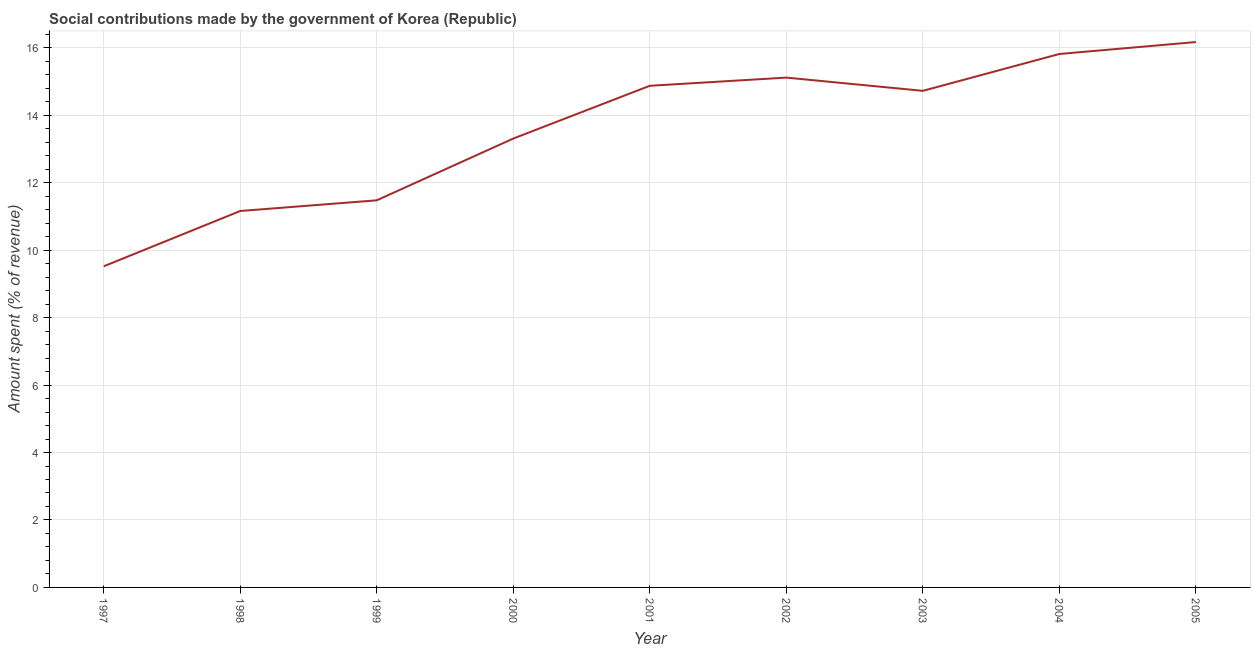What is the amount spent in making social contributions in 1997?
Offer a terse response. 9.52. Across all years, what is the maximum amount spent in making social contributions?
Give a very brief answer. 16.17. Across all years, what is the minimum amount spent in making social contributions?
Ensure brevity in your answer.  9.52. In which year was the amount spent in making social contributions maximum?
Give a very brief answer. 2005. What is the sum of the amount spent in making social contributions?
Offer a very short reply. 122.18. What is the difference between the amount spent in making social contributions in 1997 and 2002?
Offer a terse response. -5.6. What is the average amount spent in making social contributions per year?
Give a very brief answer. 13.58. What is the median amount spent in making social contributions?
Provide a short and direct response. 14.72. What is the ratio of the amount spent in making social contributions in 1999 to that in 2003?
Make the answer very short. 0.78. Is the difference between the amount spent in making social contributions in 1998 and 2003 greater than the difference between any two years?
Offer a very short reply. No. What is the difference between the highest and the second highest amount spent in making social contributions?
Keep it short and to the point. 0.35. Is the sum of the amount spent in making social contributions in 1998 and 2004 greater than the maximum amount spent in making social contributions across all years?
Provide a short and direct response. Yes. What is the difference between the highest and the lowest amount spent in making social contributions?
Your answer should be compact. 6.65. In how many years, is the amount spent in making social contributions greater than the average amount spent in making social contributions taken over all years?
Your answer should be compact. 5. Does the amount spent in making social contributions monotonically increase over the years?
Ensure brevity in your answer.  No. How many lines are there?
Keep it short and to the point. 1. What is the difference between two consecutive major ticks on the Y-axis?
Provide a short and direct response. 2. Are the values on the major ticks of Y-axis written in scientific E-notation?
Make the answer very short. No. Does the graph contain grids?
Provide a short and direct response. Yes. What is the title of the graph?
Ensure brevity in your answer.  Social contributions made by the government of Korea (Republic). What is the label or title of the X-axis?
Offer a terse response. Year. What is the label or title of the Y-axis?
Provide a short and direct response. Amount spent (% of revenue). What is the Amount spent (% of revenue) of 1997?
Your response must be concise. 9.52. What is the Amount spent (% of revenue) in 1998?
Provide a succinct answer. 11.16. What is the Amount spent (% of revenue) in 1999?
Make the answer very short. 11.48. What is the Amount spent (% of revenue) in 2000?
Provide a short and direct response. 13.31. What is the Amount spent (% of revenue) in 2001?
Make the answer very short. 14.87. What is the Amount spent (% of revenue) of 2002?
Offer a very short reply. 15.12. What is the Amount spent (% of revenue) in 2003?
Give a very brief answer. 14.72. What is the Amount spent (% of revenue) of 2004?
Keep it short and to the point. 15.82. What is the Amount spent (% of revenue) of 2005?
Make the answer very short. 16.17. What is the difference between the Amount spent (% of revenue) in 1997 and 1998?
Offer a terse response. -1.64. What is the difference between the Amount spent (% of revenue) in 1997 and 1999?
Provide a short and direct response. -1.96. What is the difference between the Amount spent (% of revenue) in 1997 and 2000?
Your answer should be compact. -3.79. What is the difference between the Amount spent (% of revenue) in 1997 and 2001?
Offer a terse response. -5.35. What is the difference between the Amount spent (% of revenue) in 1997 and 2002?
Make the answer very short. -5.6. What is the difference between the Amount spent (% of revenue) in 1997 and 2003?
Your answer should be compact. -5.2. What is the difference between the Amount spent (% of revenue) in 1997 and 2004?
Give a very brief answer. -6.3. What is the difference between the Amount spent (% of revenue) in 1997 and 2005?
Provide a succinct answer. -6.65. What is the difference between the Amount spent (% of revenue) in 1998 and 1999?
Keep it short and to the point. -0.32. What is the difference between the Amount spent (% of revenue) in 1998 and 2000?
Make the answer very short. -2.15. What is the difference between the Amount spent (% of revenue) in 1998 and 2001?
Keep it short and to the point. -3.71. What is the difference between the Amount spent (% of revenue) in 1998 and 2002?
Offer a very short reply. -3.96. What is the difference between the Amount spent (% of revenue) in 1998 and 2003?
Your answer should be compact. -3.56. What is the difference between the Amount spent (% of revenue) in 1998 and 2004?
Ensure brevity in your answer.  -4.66. What is the difference between the Amount spent (% of revenue) in 1998 and 2005?
Give a very brief answer. -5.01. What is the difference between the Amount spent (% of revenue) in 1999 and 2000?
Offer a very short reply. -1.83. What is the difference between the Amount spent (% of revenue) in 1999 and 2001?
Your response must be concise. -3.4. What is the difference between the Amount spent (% of revenue) in 1999 and 2002?
Make the answer very short. -3.64. What is the difference between the Amount spent (% of revenue) in 1999 and 2003?
Your answer should be compact. -3.25. What is the difference between the Amount spent (% of revenue) in 1999 and 2004?
Your answer should be compact. -4.34. What is the difference between the Amount spent (% of revenue) in 1999 and 2005?
Your answer should be compact. -4.69. What is the difference between the Amount spent (% of revenue) in 2000 and 2001?
Ensure brevity in your answer.  -1.56. What is the difference between the Amount spent (% of revenue) in 2000 and 2002?
Your answer should be compact. -1.81. What is the difference between the Amount spent (% of revenue) in 2000 and 2003?
Your answer should be compact. -1.41. What is the difference between the Amount spent (% of revenue) in 2000 and 2004?
Ensure brevity in your answer.  -2.51. What is the difference between the Amount spent (% of revenue) in 2000 and 2005?
Keep it short and to the point. -2.86. What is the difference between the Amount spent (% of revenue) in 2001 and 2002?
Provide a succinct answer. -0.24. What is the difference between the Amount spent (% of revenue) in 2001 and 2003?
Keep it short and to the point. 0.15. What is the difference between the Amount spent (% of revenue) in 2001 and 2004?
Offer a very short reply. -0.94. What is the difference between the Amount spent (% of revenue) in 2001 and 2005?
Your response must be concise. -1.3. What is the difference between the Amount spent (% of revenue) in 2002 and 2003?
Make the answer very short. 0.39. What is the difference between the Amount spent (% of revenue) in 2002 and 2004?
Make the answer very short. -0.7. What is the difference between the Amount spent (% of revenue) in 2002 and 2005?
Your answer should be compact. -1.05. What is the difference between the Amount spent (% of revenue) in 2003 and 2004?
Your answer should be very brief. -1.09. What is the difference between the Amount spent (% of revenue) in 2003 and 2005?
Offer a very short reply. -1.45. What is the difference between the Amount spent (% of revenue) in 2004 and 2005?
Offer a very short reply. -0.35. What is the ratio of the Amount spent (% of revenue) in 1997 to that in 1998?
Offer a very short reply. 0.85. What is the ratio of the Amount spent (% of revenue) in 1997 to that in 1999?
Keep it short and to the point. 0.83. What is the ratio of the Amount spent (% of revenue) in 1997 to that in 2000?
Ensure brevity in your answer.  0.71. What is the ratio of the Amount spent (% of revenue) in 1997 to that in 2001?
Ensure brevity in your answer.  0.64. What is the ratio of the Amount spent (% of revenue) in 1997 to that in 2002?
Your answer should be very brief. 0.63. What is the ratio of the Amount spent (% of revenue) in 1997 to that in 2003?
Give a very brief answer. 0.65. What is the ratio of the Amount spent (% of revenue) in 1997 to that in 2004?
Provide a succinct answer. 0.6. What is the ratio of the Amount spent (% of revenue) in 1997 to that in 2005?
Offer a very short reply. 0.59. What is the ratio of the Amount spent (% of revenue) in 1998 to that in 1999?
Make the answer very short. 0.97. What is the ratio of the Amount spent (% of revenue) in 1998 to that in 2000?
Make the answer very short. 0.84. What is the ratio of the Amount spent (% of revenue) in 1998 to that in 2002?
Offer a very short reply. 0.74. What is the ratio of the Amount spent (% of revenue) in 1998 to that in 2003?
Ensure brevity in your answer.  0.76. What is the ratio of the Amount spent (% of revenue) in 1998 to that in 2004?
Offer a very short reply. 0.71. What is the ratio of the Amount spent (% of revenue) in 1998 to that in 2005?
Keep it short and to the point. 0.69. What is the ratio of the Amount spent (% of revenue) in 1999 to that in 2000?
Provide a short and direct response. 0.86. What is the ratio of the Amount spent (% of revenue) in 1999 to that in 2001?
Make the answer very short. 0.77. What is the ratio of the Amount spent (% of revenue) in 1999 to that in 2002?
Provide a succinct answer. 0.76. What is the ratio of the Amount spent (% of revenue) in 1999 to that in 2003?
Make the answer very short. 0.78. What is the ratio of the Amount spent (% of revenue) in 1999 to that in 2004?
Your answer should be very brief. 0.73. What is the ratio of the Amount spent (% of revenue) in 1999 to that in 2005?
Offer a terse response. 0.71. What is the ratio of the Amount spent (% of revenue) in 2000 to that in 2001?
Ensure brevity in your answer.  0.9. What is the ratio of the Amount spent (% of revenue) in 2000 to that in 2003?
Ensure brevity in your answer.  0.9. What is the ratio of the Amount spent (% of revenue) in 2000 to that in 2004?
Provide a short and direct response. 0.84. What is the ratio of the Amount spent (% of revenue) in 2000 to that in 2005?
Keep it short and to the point. 0.82. What is the ratio of the Amount spent (% of revenue) in 2001 to that in 2002?
Ensure brevity in your answer.  0.98. What is the ratio of the Amount spent (% of revenue) in 2001 to that in 2003?
Provide a succinct answer. 1.01. What is the ratio of the Amount spent (% of revenue) in 2001 to that in 2005?
Keep it short and to the point. 0.92. What is the ratio of the Amount spent (% of revenue) in 2002 to that in 2003?
Your answer should be compact. 1.03. What is the ratio of the Amount spent (% of revenue) in 2002 to that in 2004?
Provide a short and direct response. 0.96. What is the ratio of the Amount spent (% of revenue) in 2002 to that in 2005?
Keep it short and to the point. 0.94. What is the ratio of the Amount spent (% of revenue) in 2003 to that in 2004?
Make the answer very short. 0.93. What is the ratio of the Amount spent (% of revenue) in 2003 to that in 2005?
Your answer should be compact. 0.91. 